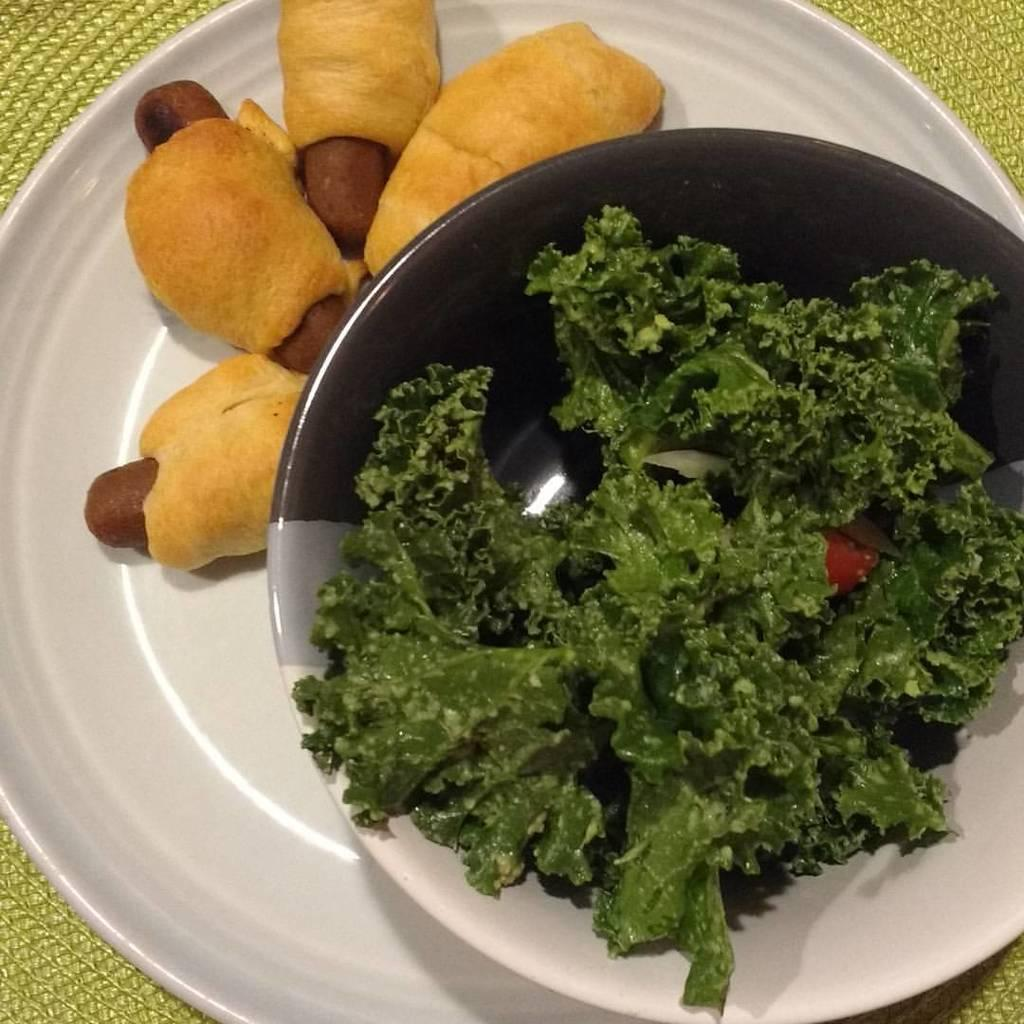What is present on the platform in the image? There is a plate, food, vegetables, and a bowl on the platform in the image. Can you describe the type of food in the image? The food in the image consists of vegetables. What is the container for the vegetables in the image? The vegetables are in a bowl in the image. How are the plate, bowl, and food arranged on the platform? All of these items are on a platform, but the specific arrangement cannot be determined from the provided facts. What type of volleyball is being used to distribute the vegetables in the image? There is no volleyball present in the image, and vegetables are not being distributed. What kind of rock can be seen supporting the platform in the image? There is no rock visible in the image; the platform's support is not described in the provided facts. 